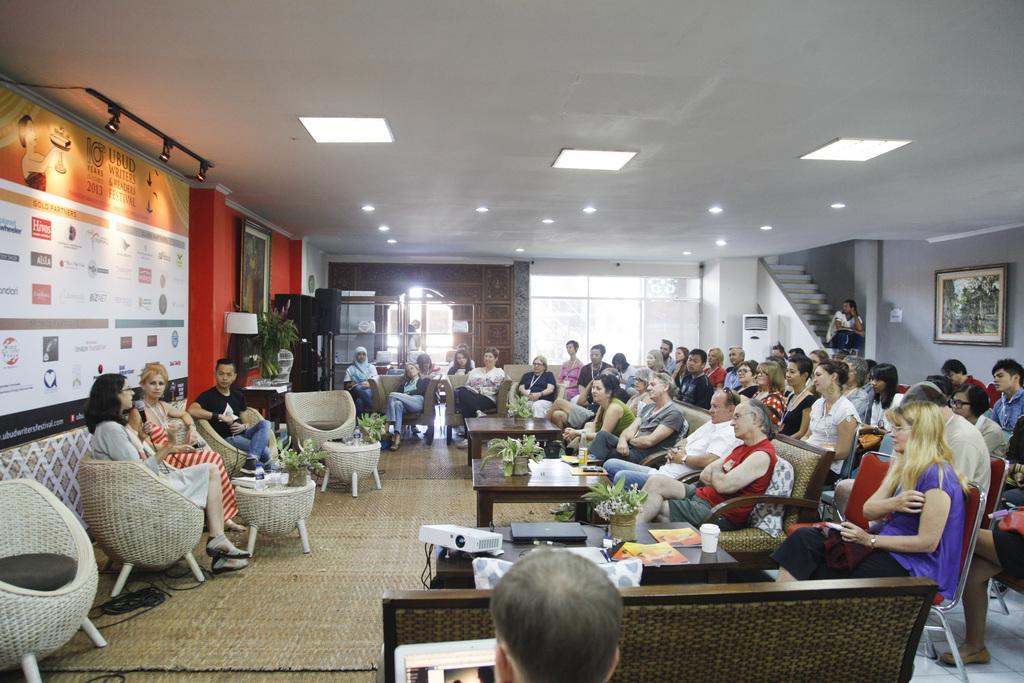How would you summarize this image in a sentence or two? In this image there are group of people sitting in chair and the back ground there is hoarding , lights , chair , plants , table , staircase , air conditioner , frame. 